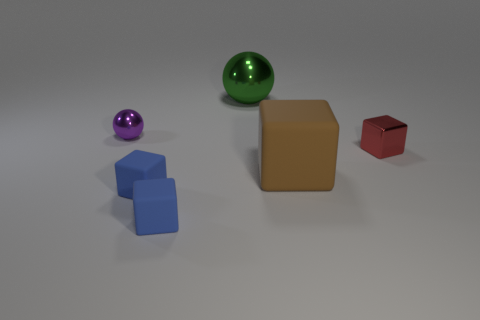Subtract all red cubes. How many cubes are left? 3 Subtract all matte cubes. How many cubes are left? 1 Add 4 big brown cubes. How many objects exist? 10 Subtract all balls. How many objects are left? 4 Subtract all cyan blocks. Subtract all red balls. How many blocks are left? 4 Add 4 red blocks. How many red blocks exist? 5 Subtract 0 green cylinders. How many objects are left? 6 Subtract all tiny spheres. Subtract all small metallic blocks. How many objects are left? 4 Add 1 matte blocks. How many matte blocks are left? 4 